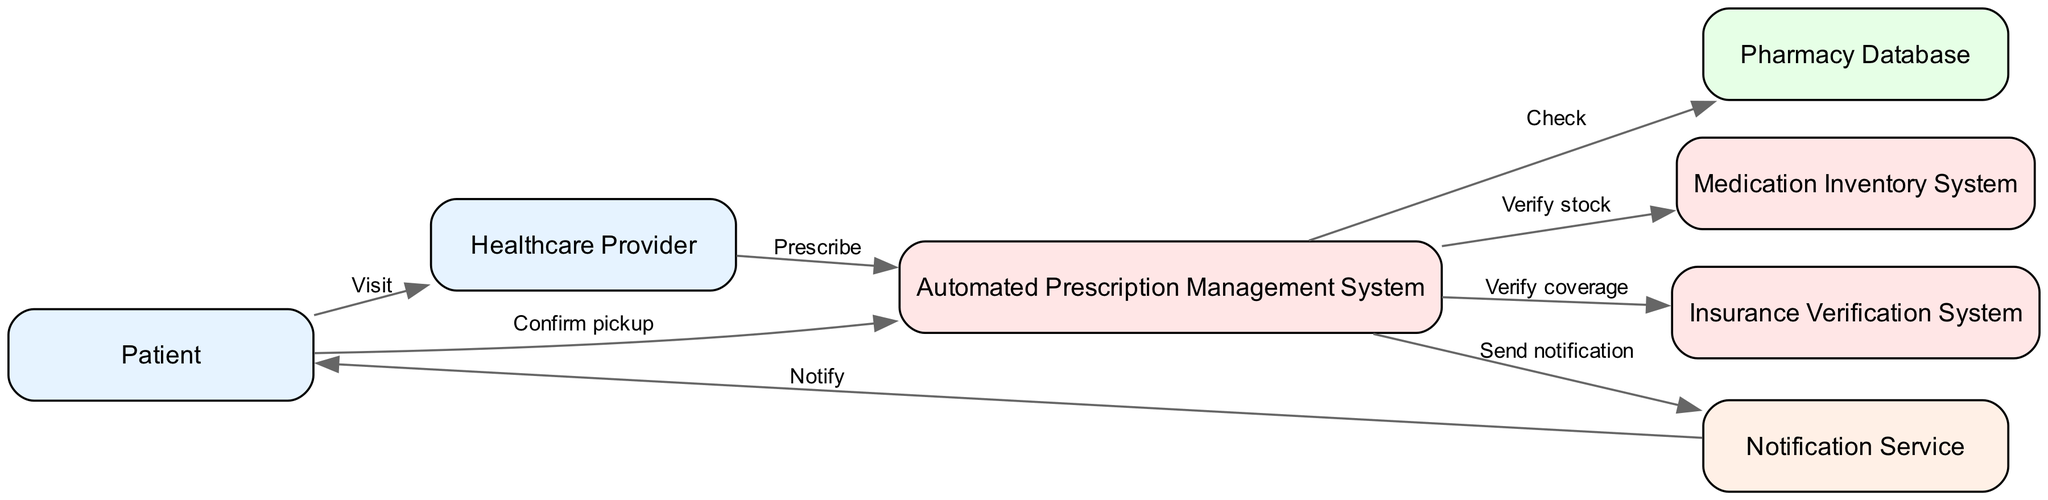What is the total number of nodes in the diagram? The nodes in the diagram include: Patient, Healthcare Provider, Automated Prescription Management System, Pharmacy Database, Medication Inventory System, Insurance Verification System, and Notification Service. Counting all of them gives us a total of 7 nodes.
Answer: 7 What action does the Healthcare Provider perform with the Automated Prescription Management System? According to the diagram, the Healthcare Provider has an interaction labeled "Prescribe" with the Automated Prescription Management System, indicating the action they take.
Answer: Prescribe Which actor receives notifications from the Notification Service? In the diagram, the notification flow is directed from the Notification Service to the Patient, suggesting that the Patient is the recipient of these notifications.
Answer: Patient How many interactions occur between the Patient and the Automated Prescription Management System? In the diagram, the Patient interacts with the Automated Prescription Management System twice: first by confirming the pickup and second by notifying the Patient via the Notification Service. This means there are two distinct interactions counting both directions.
Answer: 2 What is the first action taken in the sequence of interactions? The first action in the sequence is the Patient visiting the Healthcare Provider, which initiates the interaction flow depicted in the diagram.
Answer: Visit Which system checks the coverage for the patient's prescription? The interaction labeled "Verify coverage" indicates that the Automated Prescription Management System uses the Insurance Verification System to check the patient's coverage for the prescription.
Answer: Insurance Verification System What role does the Medication Inventory System play in the prescription process? The diagram indicates that the Automated Prescription Management System interacts with the Medication Inventory System to "Verify stock," suggesting that it ensures the medication is available before proceeding.
Answer: Verify stock How many services are represented in the diagram? Scanning through the diagram, only one service is shown: the Notification Service, which is involved in notifying the Patient. Hence, there is only one service represented in the diagram.
Answer: 1 What follows the action of "Check" in the sequence? After the "Check" action from the Automated Prescription Management System to the Pharmacy Database, it interacts with the Medication Inventory System with the action labeled "Verify stock," indicating it's the next sequential step.
Answer: Verify stock 